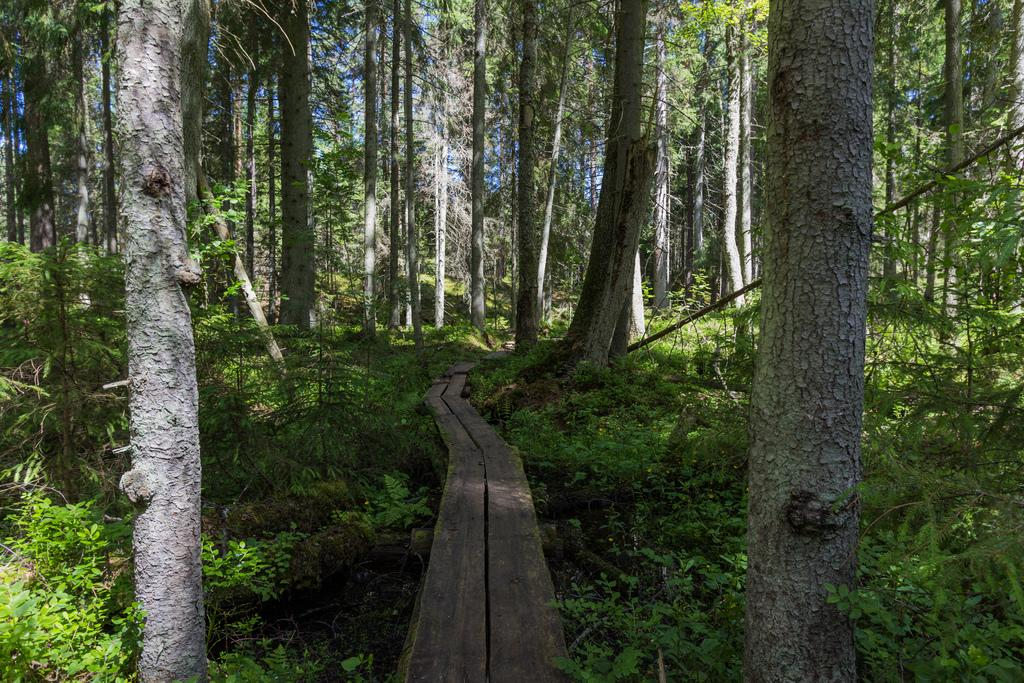What is the main feature in the center of the image? There is a wooden path in the center of the image. What type of vegetation can be seen around the area in the image? There are trees around the area of the image. Is your uncle participating in the event happening on the wooden path in the image? There is no mention of an uncle or an event in the image, so we cannot answer this question. 